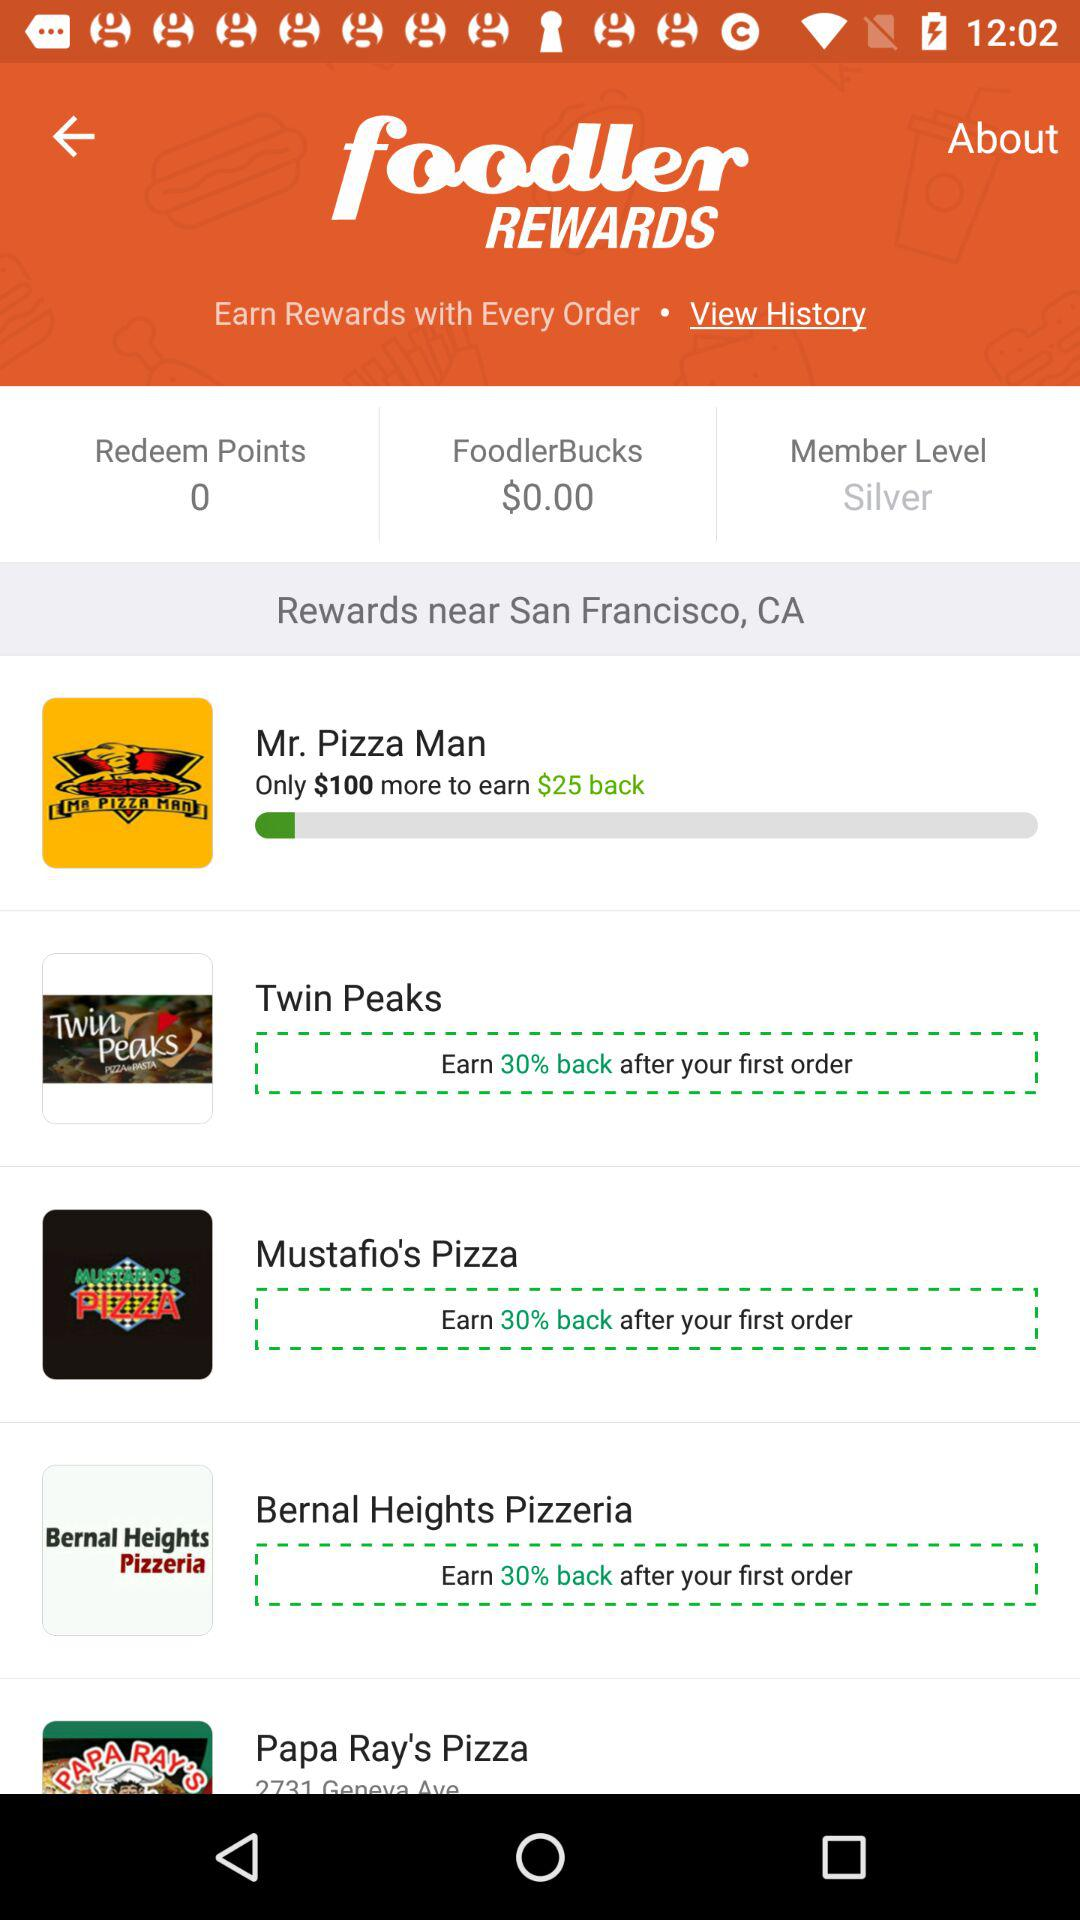How many businesses offer a 30% return on my first order?
Answer the question using a single word or phrase. 3 